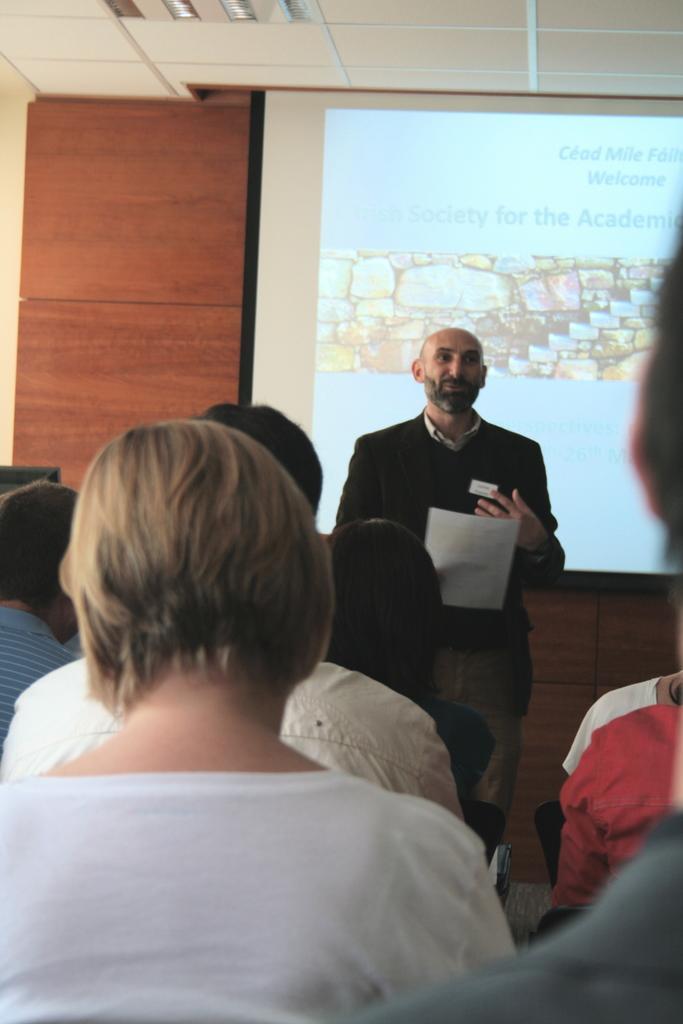Please provide a concise description of this image. In this image I can see number of people where in the front I can see most of them are sitting and in the background I can see one person is standing and holding a white color paper. I can also see a projector screen in the background and on it I can see something is written. 